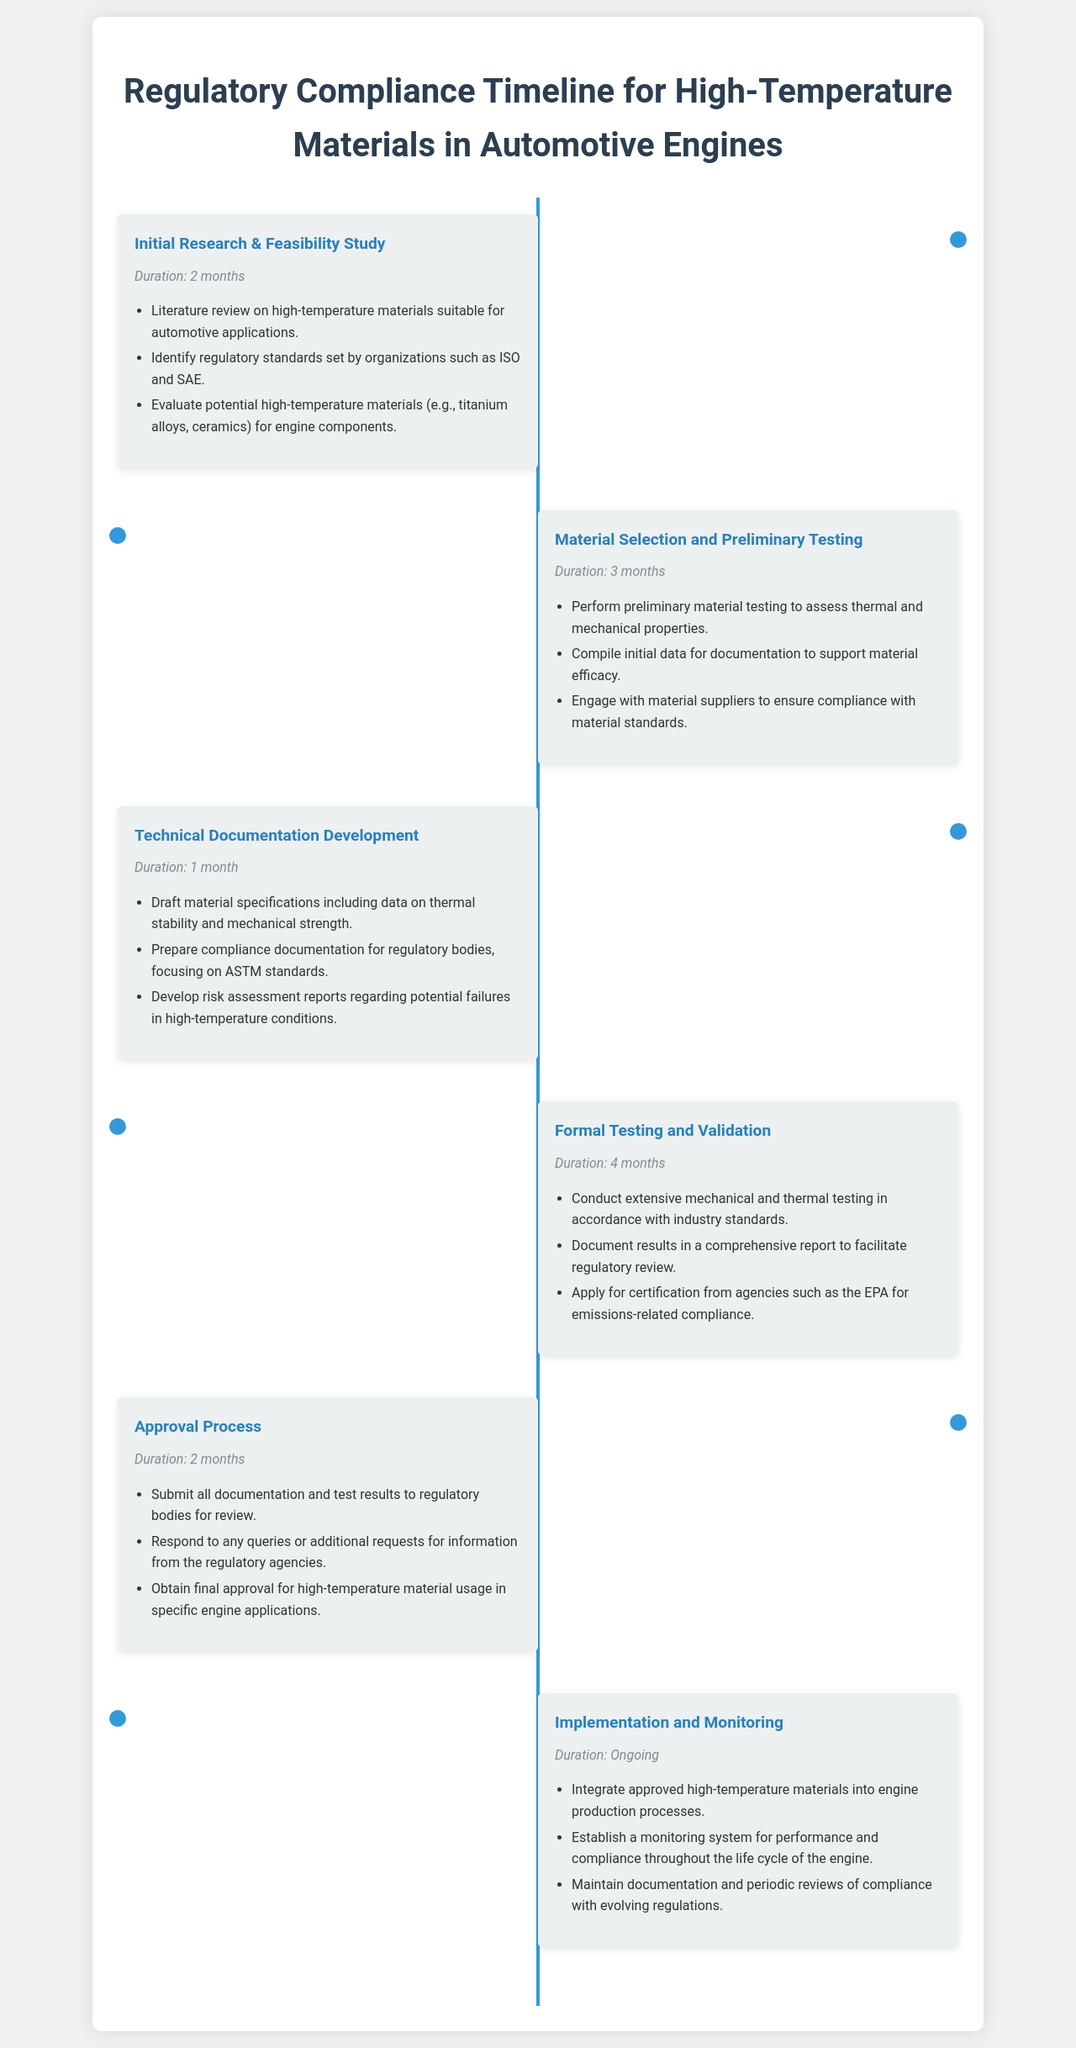What is the duration of the Initial Research phase? The duration of the Initial Research phase is mentioned as 2 months in the document.
Answer: 2 months How many phases are listed in the timeline? The timeline contains a total of 6 phases related to high-temperature materials compliance.
Answer: 6 phases Which phase involves drafting material specifications? The phase that involves drafting material specifications is Technical Documentation Development.
Answer: Technical Documentation Development What is the duration of the Formal Testing and Validation phase? The duration for the Formal Testing and Validation phase is specified as 4 months in the timeline.
Answer: 4 months What is required during the Approval Process phase? During the Approval Process phase, all documentation and test results must be submitted to regulatory bodies for review.
Answer: Submission of documentation What ongoing activity is mentioned in the Implementation phase? An ongoing activity mentioned in the Implementation phase is to establish a monitoring system for performance and compliance.
Answer: Monitoring system Which materials are evaluated in the Initial Research phase? The Initial Research phase evaluates potential high-temperature materials such as titanium alloys and ceramics.
Answer: Titanium alloys, ceramics What certification is mentioned for the Formal Testing phase? For the Formal Testing phase, certification from agencies such as the EPA for emissions-related compliance is mentioned.
Answer: EPA certification How long does the Approval Process take? The Approval Process phase duration is explicitly stated as 2 months in the document.
Answer: 2 months 